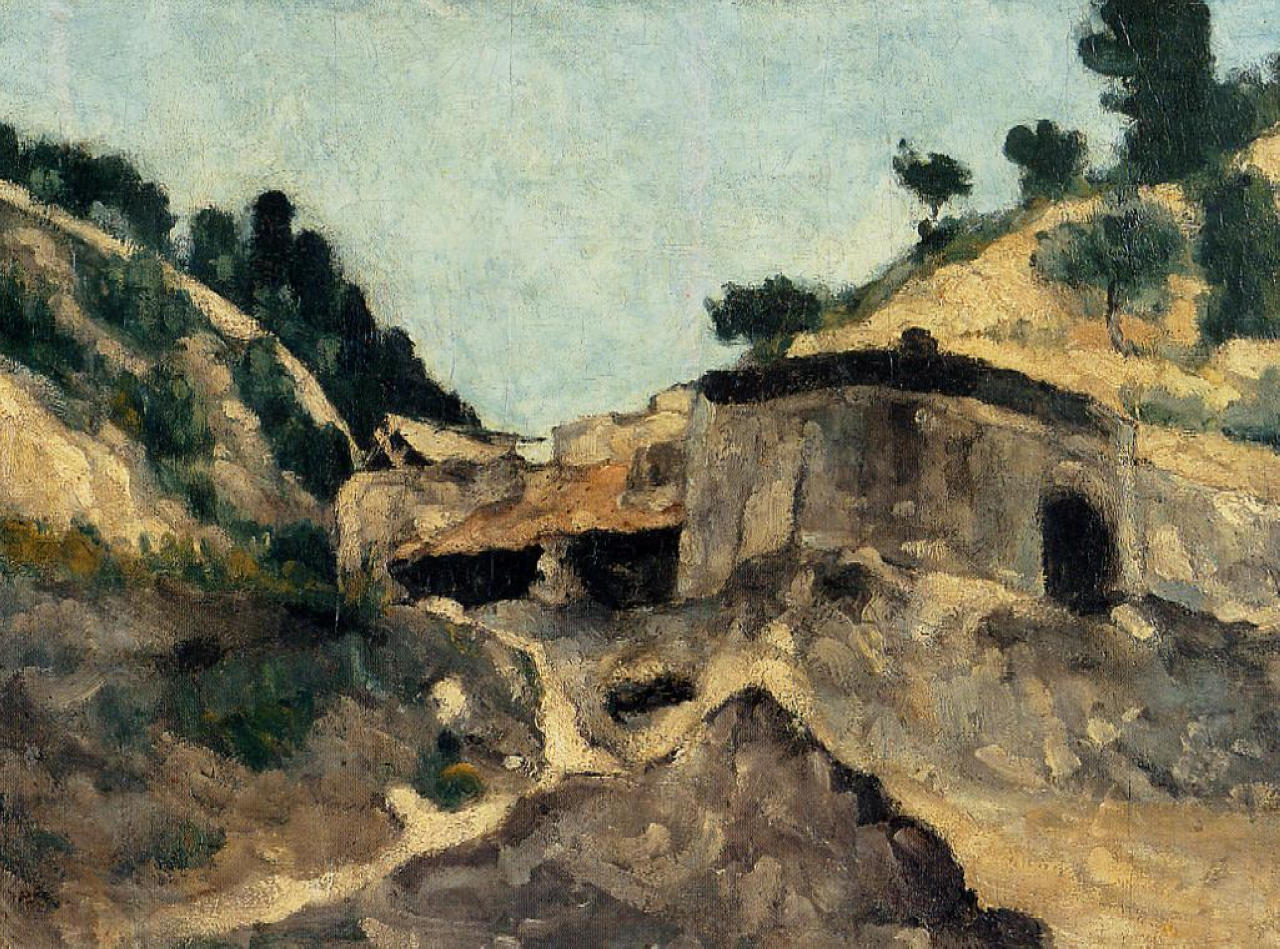Imagine a fantastical event happening in this scene. What do you see? Picture the old stone building transforming into a magical academy at the stroke of midnight. Silvery moonlight would illuminate the structure, revealing hidden runes etched into the stones, glowing with ethereal light. Trees come alive, their branches forming arching pathways leading towards a secret underground library. The rolling hills would unfurl like ancient scrolls, revealing hidden worlds and mythical creatures emerging from the earth. The sky would shimmer with constellations rearranging themselves, telling tales of forgotten lore as mystical birds, with feathers of stardust, take flight across the serene blue expanse. In this mesmerizing spectacle, time weaves seamlessly into fantasy, creating an unforgettable moment of wonder. 